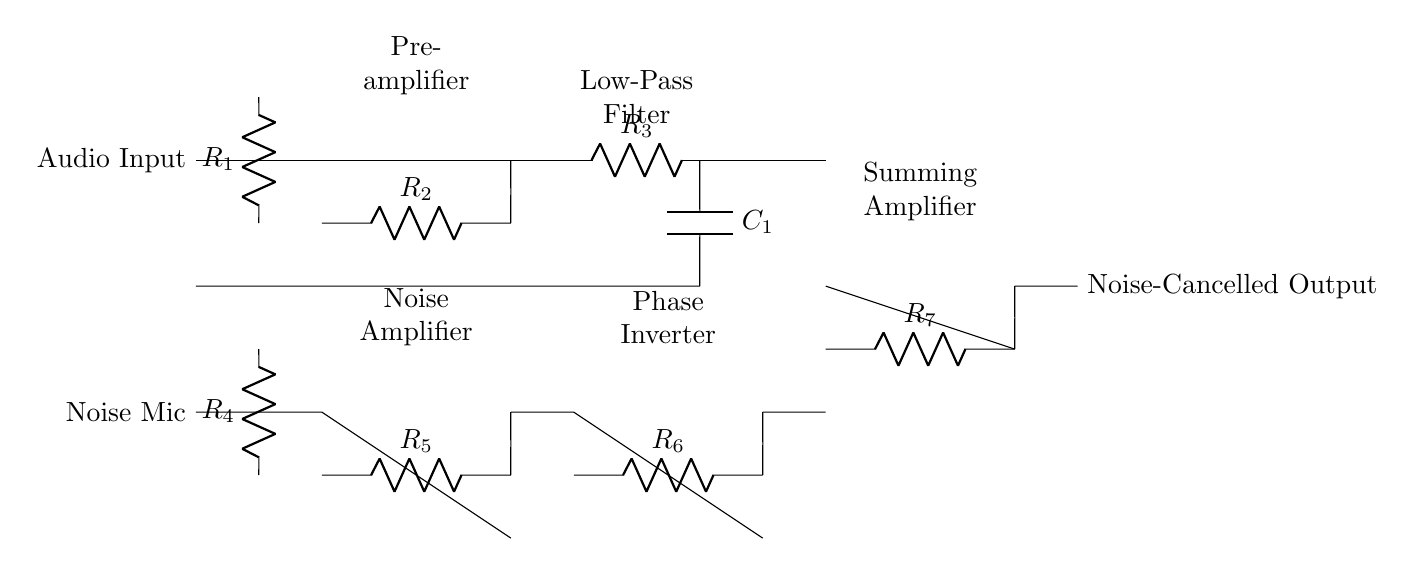What is the first component after the audio input? The first component in the circuit after the audio input is a resistor labeled R1. It serves as a current limiting and signal conditioning device.
Answer: R1 What follows the preamplifier section in the circuit? After the preamplifier section, which is made up of the operational amplifier and resistor R2, comes the low-pass filter consisting of resistor R3 and capacitor C1. This section helps filter high-frequency noise.
Answer: Low-Pass Filter How many operational amplifiers are in this circuit? There are five operational amplifiers present in the circuit: one in the preamplifier, one in the noise amplifier, one in the phase inverter, and one in the summing amplifier.
Answer: Five What is the role of the noise detection microphone? The noise detection microphone captures ambient noise and sends it through a resistor, which reduces its level before it is amplified in the noise amplifier section.
Answer: Capture noise Why is a low-pass filter used in this circuit? A low-pass filter is utilized in this circuit to allow low-frequency audio signals to pass while attenuating high-frequency noise that could degrade audio quality. This enhances the overall sound quality in gaming areas by eliminating unwanted noise.
Answer: Attenuate noise What component is labeled R7 connected to in this circuit? The resistor labeled R7 is connected to the summing amplifier. It combines the outputs from the preamplifier and the phase inverter, thereby contributing to the overall noise cancellation process.
Answer: Summing amplifier What does the output of this circuit represent? The output of this circuit represents the noise-cancelled audio signal, which is delivered to the output for further processing or amplification to improve audio quality for the gaming area.
Answer: Noise-Cancelled Output 